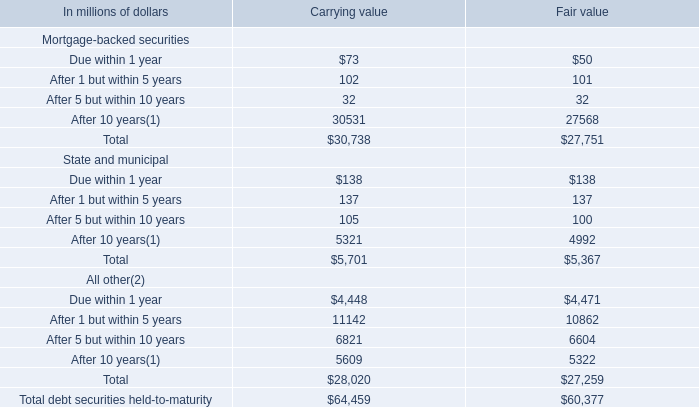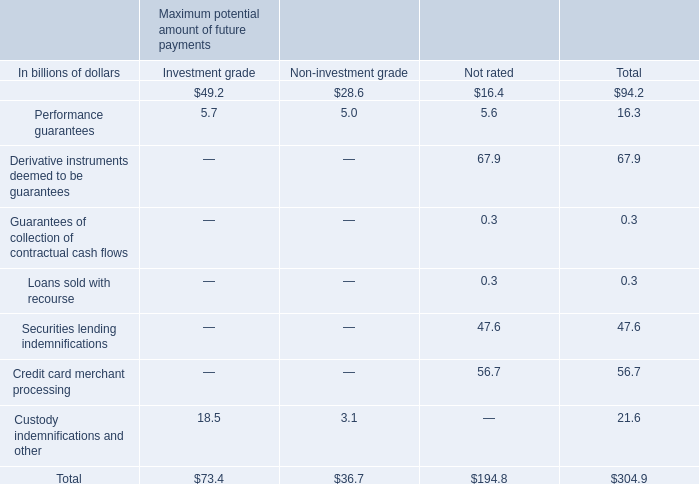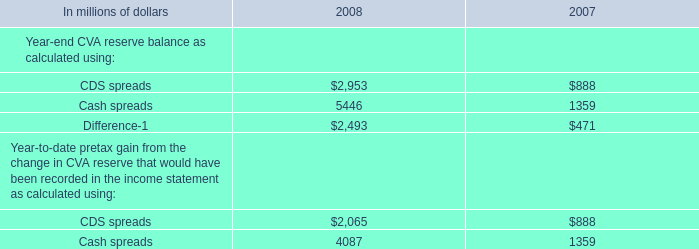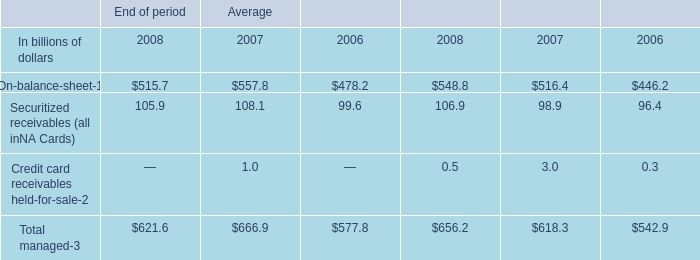What is the total amount of Cash spreads of 2007, After 10 years of Fair value, and After 10 years State and municipal of Fair value ? 
Computations: ((1359.0 + 27568.0) + 4992.0)
Answer: 33919.0. 